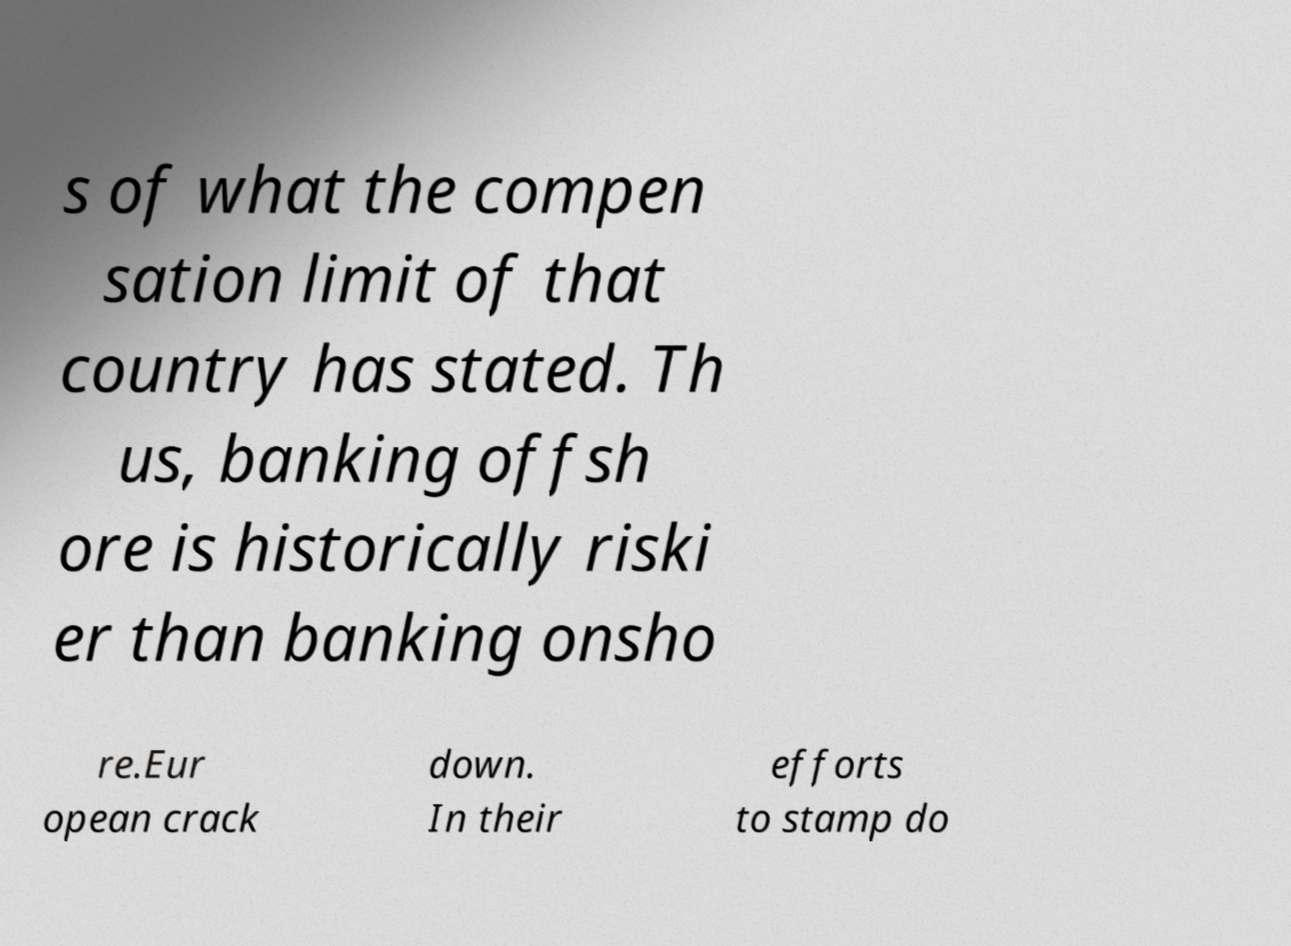I need the written content from this picture converted into text. Can you do that? s of what the compen sation limit of that country has stated. Th us, banking offsh ore is historically riski er than banking onsho re.Eur opean crack down. In their efforts to stamp do 